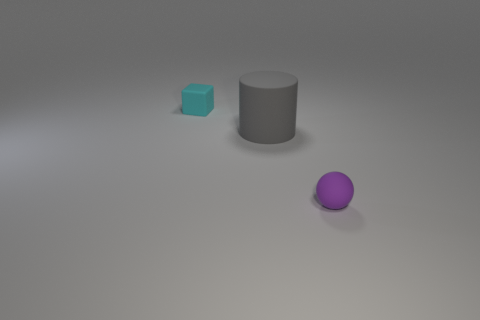What color is the tiny rubber thing behind the small thing that is right of the cylinder?
Offer a very short reply. Cyan. Is there any other thing that has the same material as the tiny block?
Provide a succinct answer. Yes. What is the material of the small thing that is behind the large rubber cylinder?
Offer a terse response. Rubber. Are there fewer large rubber objects on the left side of the big gray matte thing than tiny cyan objects?
Provide a succinct answer. Yes. There is a tiny thing behind the tiny rubber object in front of the big object; what is its shape?
Keep it short and to the point. Cube. What color is the small matte ball?
Ensure brevity in your answer.  Purple. How many other things are the same size as the ball?
Give a very brief answer. 1. The object that is on the right side of the cyan thing and to the left of the small sphere is made of what material?
Offer a very short reply. Rubber. There is a thing that is right of the gray thing; does it have the same size as the tiny cyan thing?
Keep it short and to the point. Yes. Is the sphere the same color as the big rubber object?
Your answer should be compact. No. 